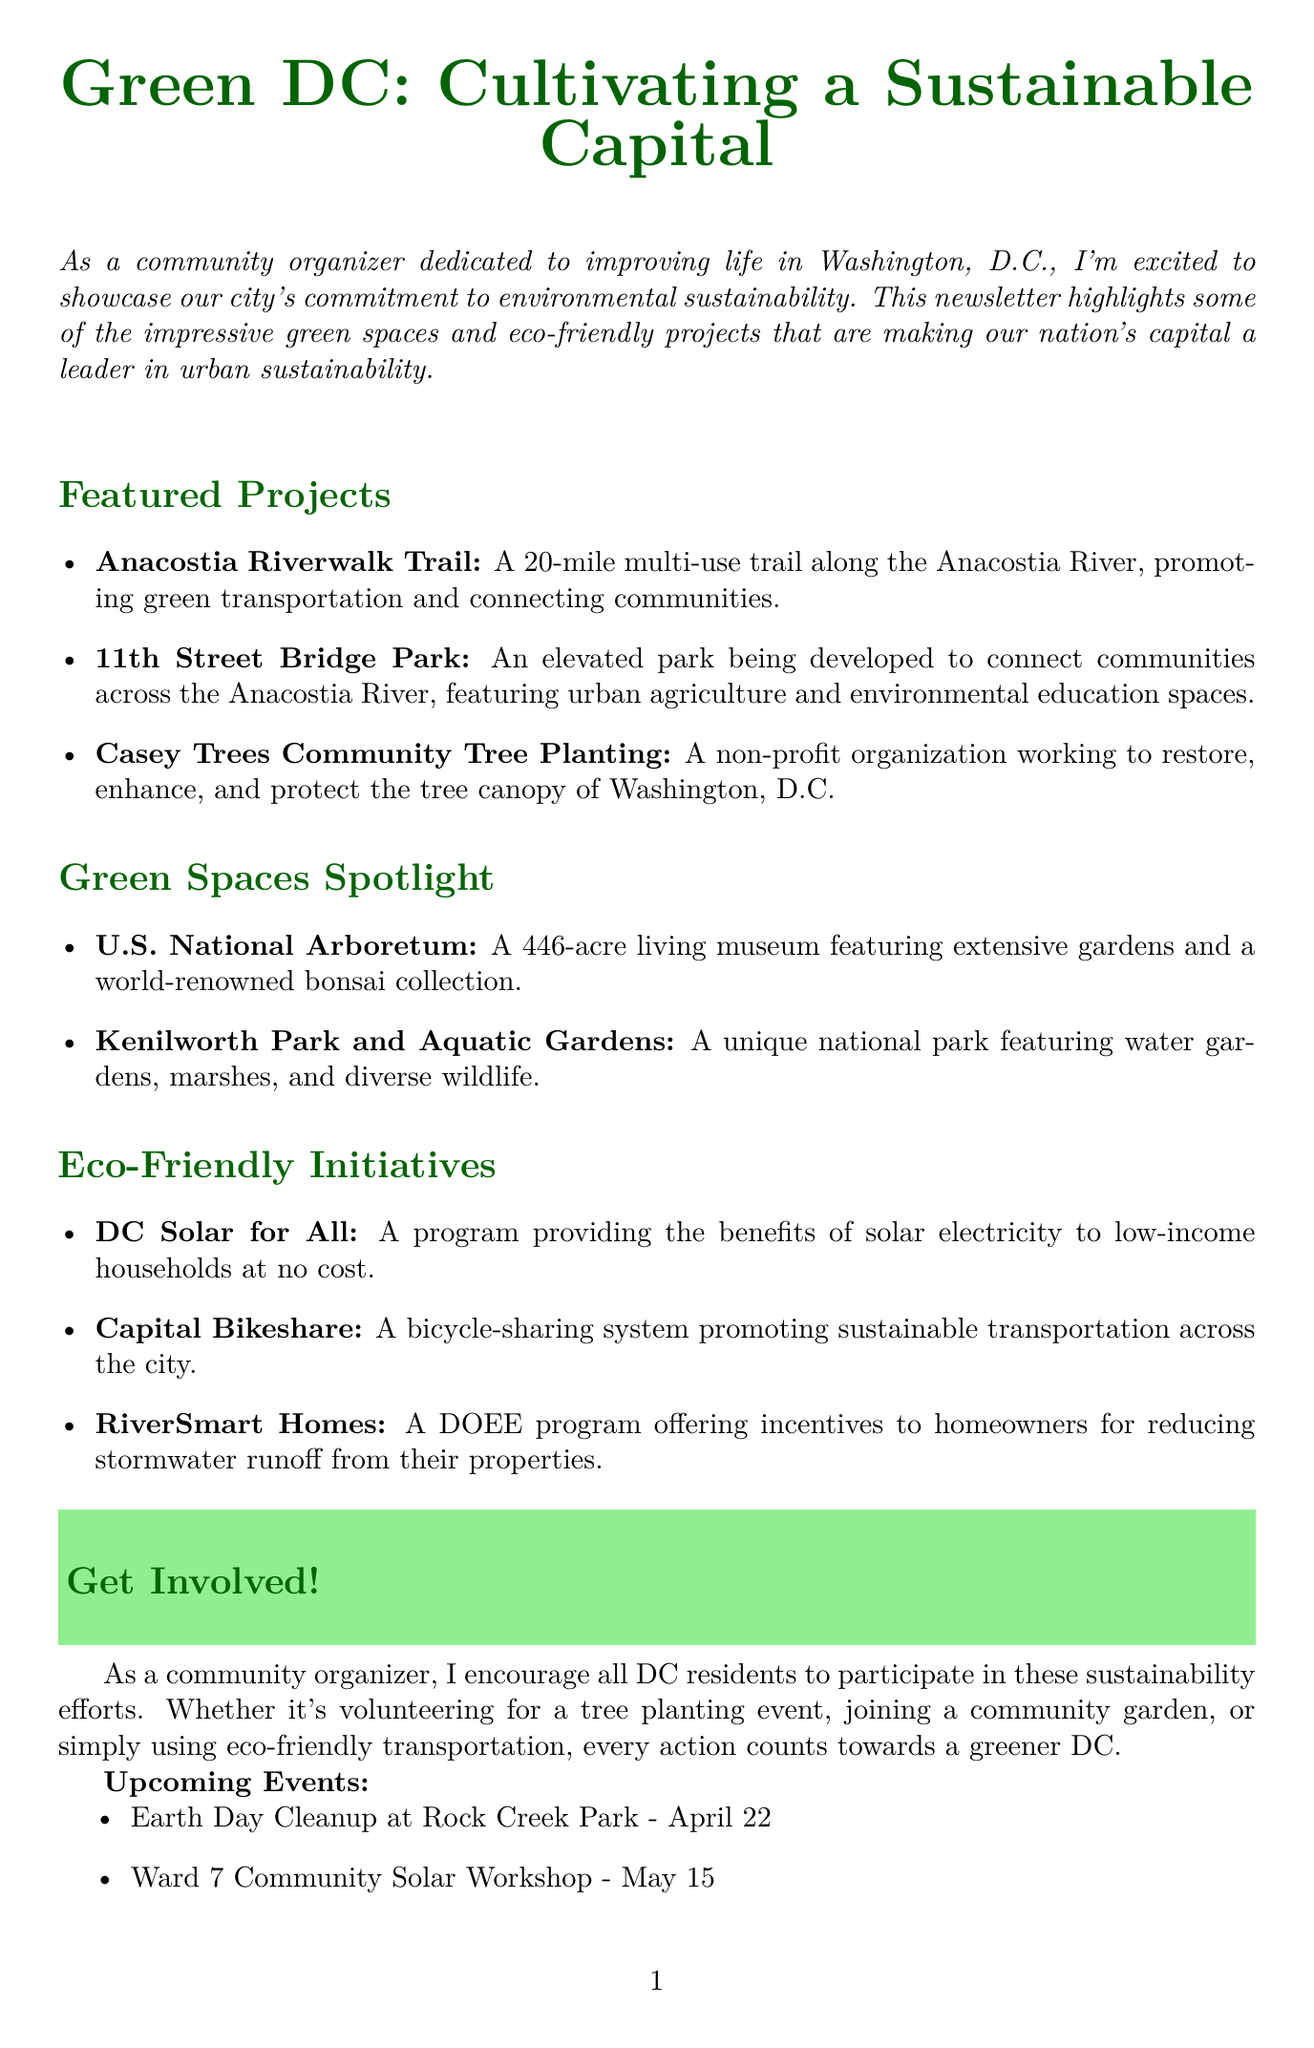What is the title of the newsletter? The title of the newsletter is prominently displayed at the beginning of the document.
Answer: Green DC: Cultivating a Sustainable Capital How many featured projects are listed? The number of featured projects is indicated by the items under the Featured Projects section.
Answer: 3 What initiative provides solar electricity to low-income households? This is clearly mentioned in the Eco-Friendly Initiatives section with a specific title.
Answer: DC Solar for All What event is scheduled for April 22? The event date is associated with the specific activity mentioned in the Upcoming Events list.
Answer: Earth Day Cleanup What is the purpose of the Anacostia Riverwalk Trail? The document provides a brief description of the trail's objectives in the Featured Projects section.
Answer: Promoting green transportation Which park features a world-renowned bonsai collection? This information is found in the Green Spaces Spotlight section.
Answer: U.S. National Arboretum What does the Casey Trees organization work to protect? The mission of the organization is clearly articulated in the description under Featured Projects.
Answer: Tree canopy How many upcoming events are listed? The count of upcoming events can be determined by counting items in the Upcoming Events section.
Answer: 3 